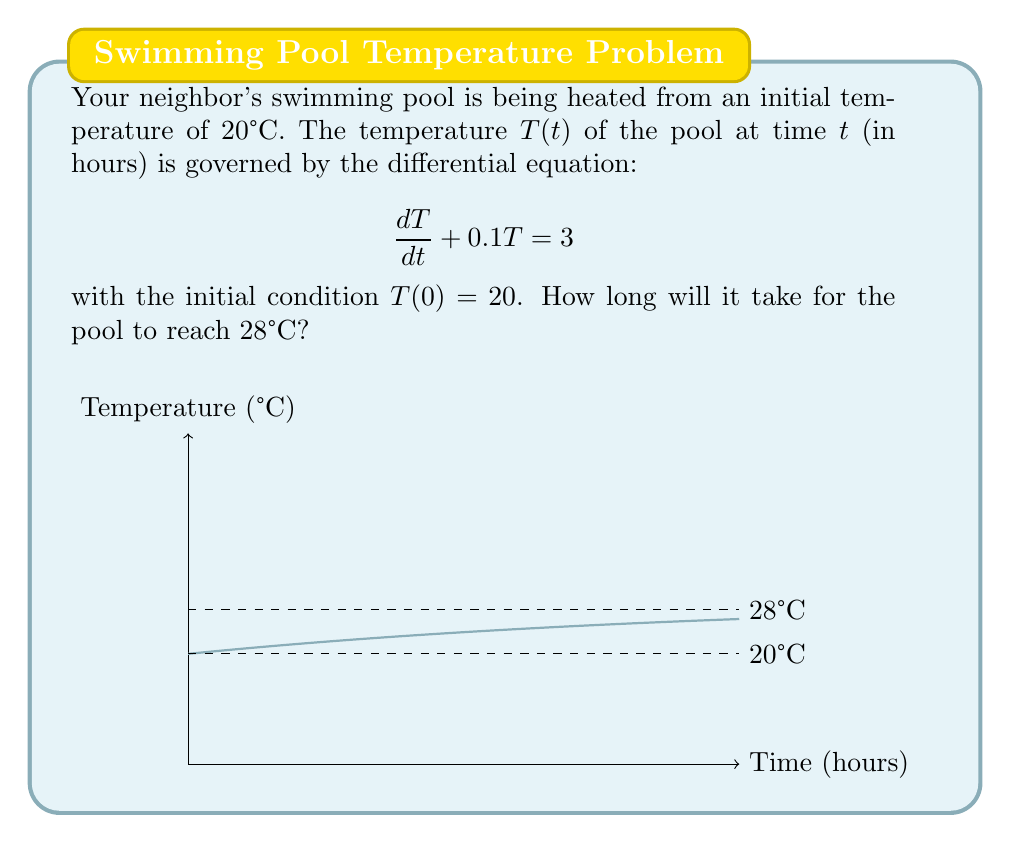Show me your answer to this math problem. Let's solve this problem step by step using the Laplace transform method:

1) First, we take the Laplace transform of both sides of the differential equation:
   $$\mathcal{L}\left\{\frac{dT}{dt}\right\} + 0.1\mathcal{L}\{T\} = \mathcal{L}\{3\}$$

2) Using the properties of Laplace transform:
   $$sT(s) - T(0) + 0.1T(s) = \frac{3}{s}$$

3) Substituting the initial condition $T(0) = 20$:
   $$sT(s) - 20 + 0.1T(s) = \frac{3}{s}$$

4) Rearranging terms:
   $$(s + 0.1)T(s) = \frac{3}{s} + 20$$

5) Solving for $T(s)$:
   $$T(s) = \frac{3}{s(s + 0.1)} + \frac{20}{s + 0.1}$$

6) Taking the inverse Laplace transform:
   $$T(t) = 30 - 10e^{-0.1t}$$

7) To find when the temperature reaches 28°C, we solve:
   $$28 = 30 - 10e^{-0.1t}$$

8) Rearranging:
   $$2 = 10e^{-0.1t}$$
   $$0.2 = e^{-0.1t}$$

9) Taking the natural log of both sides:
   $$\ln(0.2) = -0.1t$$

10) Solving for $t$:
    $$t = \frac{-\ln(0.2)}{0.1} \approx 16.1$$

Therefore, it will take approximately 16.1 hours for the pool to reach 28°C.
Answer: 16.1 hours 